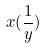<formula> <loc_0><loc_0><loc_500><loc_500>x ( \frac { 1 } { y } )</formula> 